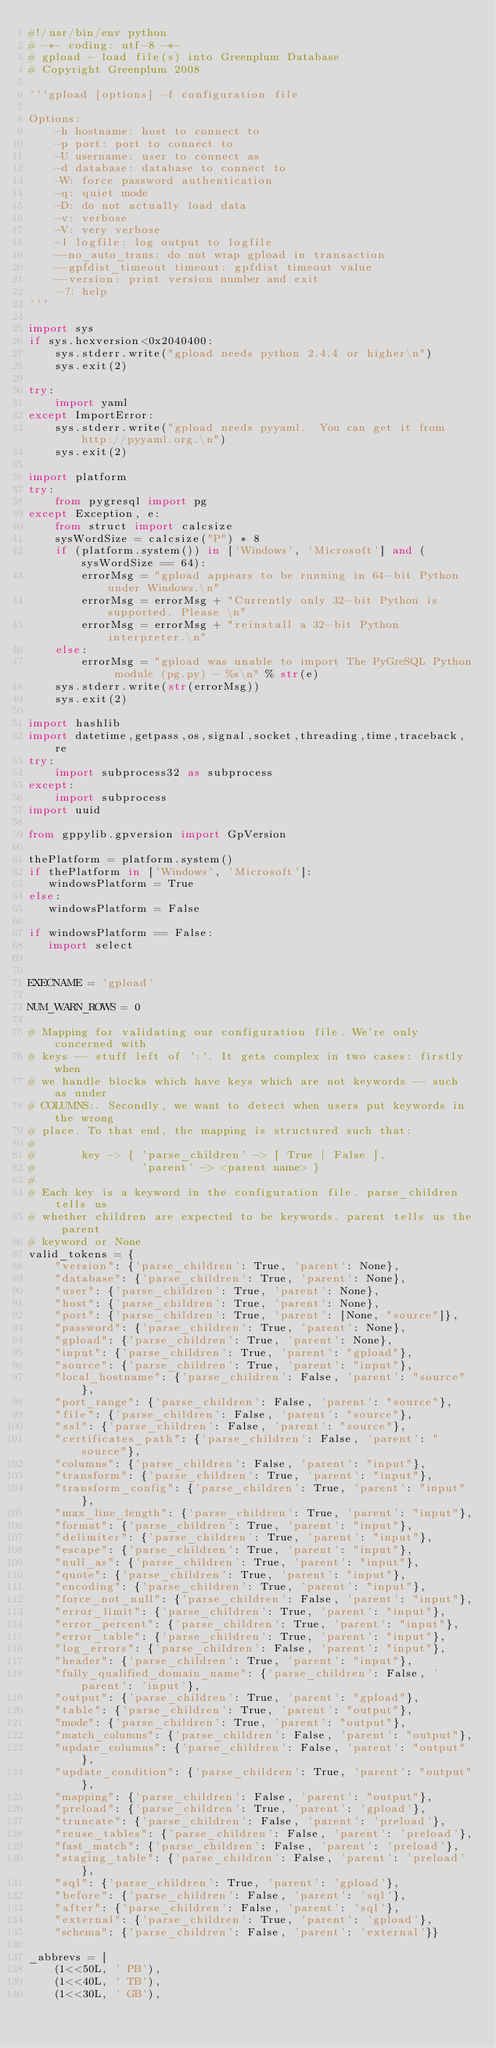<code> <loc_0><loc_0><loc_500><loc_500><_Python_>#!/usr/bin/env python
# -*- coding: utf-8 -*-
# gpload - load file(s) into Greenplum Database
# Copyright Greenplum 2008

'''gpload [options] -f configuration file

Options:
    -h hostname: host to connect to
    -p port: port to connect to
    -U username: user to connect as
    -d database: database to connect to
    -W: force password authentication
    -q: quiet mode
    -D: do not actually load data
    -v: verbose
    -V: very verbose
    -l logfile: log output to logfile
    --no_auto_trans: do not wrap gpload in transaction
    --gpfdist_timeout timeout: gpfdist timeout value
    --version: print version number and exit
    -?: help
'''

import sys
if sys.hexversion<0x2040400:
    sys.stderr.write("gpload needs python 2.4.4 or higher\n")
    sys.exit(2)

try:
    import yaml
except ImportError:
    sys.stderr.write("gpload needs pyyaml.  You can get it from http://pyyaml.org.\n")
    sys.exit(2)

import platform
try:
    from pygresql import pg
except Exception, e:
    from struct import calcsize
    sysWordSize = calcsize("P") * 8
    if (platform.system()) in ['Windows', 'Microsoft'] and (sysWordSize == 64):
        errorMsg = "gpload appears to be running in 64-bit Python under Windows.\n"
        errorMsg = errorMsg + "Currently only 32-bit Python is supported. Please \n"
        errorMsg = errorMsg + "reinstall a 32-bit Python interpreter.\n"
    else:
        errorMsg = "gpload was unable to import The PyGreSQL Python module (pg.py) - %s\n" % str(e)
    sys.stderr.write(str(errorMsg))
    sys.exit(2)

import hashlib
import datetime,getpass,os,signal,socket,threading,time,traceback,re
try:
    import subprocess32 as subprocess
except:
    import subprocess
import uuid

from gppylib.gpversion import GpVersion

thePlatform = platform.system()
if thePlatform in ['Windows', 'Microsoft']:
   windowsPlatform = True
else:
   windowsPlatform = False

if windowsPlatform == False:
   import select


EXECNAME = 'gpload'

NUM_WARN_ROWS = 0

# Mapping for validating our configuration file. We're only concerned with
# keys -- stuff left of ':'. It gets complex in two cases: firstly when
# we handle blocks which have keys which are not keywords -- such as under
# COLUMNS:. Secondly, we want to detect when users put keywords in the wrong
# place. To that end, the mapping is structured such that:
#
#       key -> { 'parse_children' -> [ True | False ],
#                'parent' -> <parent name> }
#
# Each key is a keyword in the configuration file. parse_children tells us
# whether children are expected to be keywords. parent tells us the parent
# keyword or None
valid_tokens = {
    "version": {'parse_children': True, 'parent': None},
    "database": {'parse_children': True, 'parent': None},
    "user": {'parse_children': True, 'parent': None},
    "host": {'parse_children': True, 'parent': None},
    "port": {'parse_children': True, 'parent': [None, "source"]},
    "password": {'parse_children': True, 'parent': None},
    "gpload": {'parse_children': True, 'parent': None},
    "input": {'parse_children': True, 'parent': "gpload"},
    "source": {'parse_children': True, 'parent': "input"},
    "local_hostname": {'parse_children': False, 'parent': "source"},
    "port_range": {'parse_children': False, 'parent': "source"},
    "file": {'parse_children': False, 'parent': "source"},
    "ssl": {'parse_children': False, 'parent': "source"},
    "certificates_path": {'parse_children': False, 'parent': "source"},
    "columns": {'parse_children': False, 'parent': "input"},
    "transform": {'parse_children': True, 'parent': "input"},
    "transform_config": {'parse_children': True, 'parent': "input"},
    "max_line_length": {'parse_children': True, 'parent': "input"},
    "format": {'parse_children': True, 'parent': "input"},
    "delimiter": {'parse_children': True, 'parent': "input"},
    "escape": {'parse_children': True, 'parent': "input"},
    "null_as": {'parse_children': True, 'parent': "input"},
    "quote": {'parse_children': True, 'parent': "input"},
    "encoding": {'parse_children': True, 'parent': "input"},
    "force_not_null": {'parse_children': False, 'parent': "input"},
    "error_limit": {'parse_children': True, 'parent': "input"},
    "error_percent": {'parse_children': True, 'parent': "input"},
    "error_table": {'parse_children': True, 'parent': "input"},
    "log_errors": {'parse_children': False, 'parent': "input"},
    "header": {'parse_children': True, 'parent': "input"},
    "fully_qualified_domain_name": {'parse_children': False, 'parent': 'input'},
    "output": {'parse_children': True, 'parent': "gpload"},
    "table": {'parse_children': True, 'parent': "output"},
    "mode": {'parse_children': True, 'parent': "output"},
    "match_columns": {'parse_children': False, 'parent': "output"},
    "update_columns": {'parse_children': False, 'parent': "output"},
    "update_condition": {'parse_children': True, 'parent': "output"},
    "mapping": {'parse_children': False, 'parent': "output"},
    "preload": {'parse_children': True, 'parent': 'gpload'},
    "truncate": {'parse_children': False, 'parent': 'preload'},
    "reuse_tables": {'parse_children': False, 'parent': 'preload'},
    "fast_match": {'parse_children': False, 'parent': 'preload'},
    "staging_table": {'parse_children': False, 'parent': 'preload'},
    "sql": {'parse_children': True, 'parent': 'gpload'},
    "before": {'parse_children': False, 'parent': 'sql'},
    "after": {'parse_children': False, 'parent': 'sql'},
    "external": {'parse_children': True, 'parent': 'gpload'},
    "schema": {'parse_children': False, 'parent': 'external'}}

_abbrevs = [
    (1<<50L, ' PB'),
    (1<<40L, ' TB'),
    (1<<30L, ' GB'),</code> 